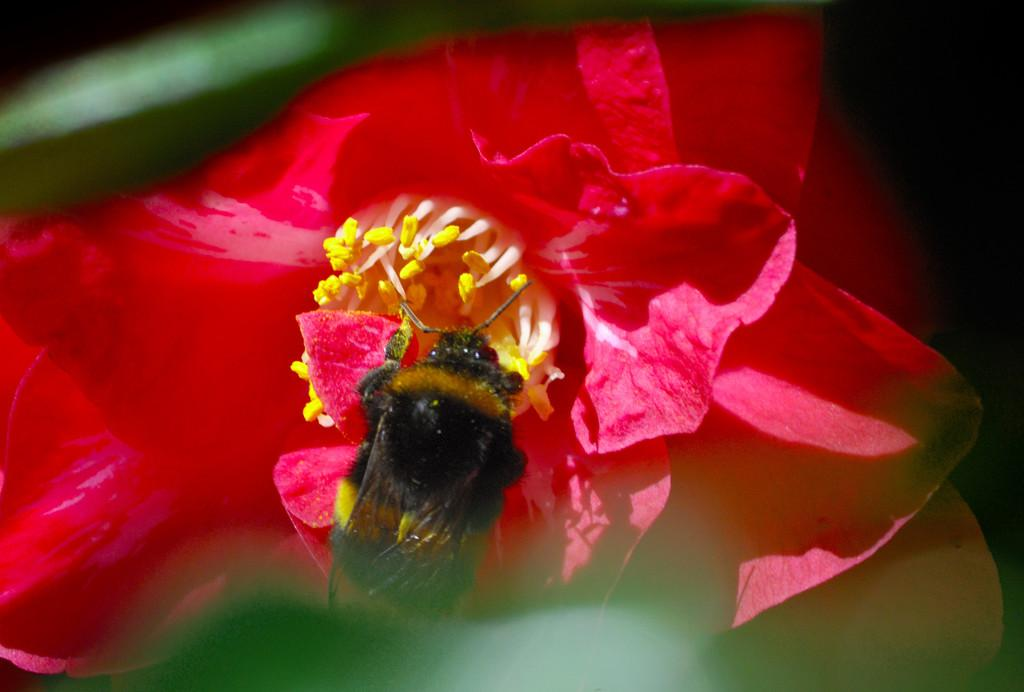What is present on the flower in the image? There is a bug on the flower in the image. Where is the flower located in the image? The flower is in the center of the image. What type of lift can be seen in the image? There is no lift present in the image; it features a bug on a flower. What suggestion does the bug have for the flower in the image? The image does not provide any information about the bug's thoughts or intentions, so it is impossible to determine any suggestions it might have. 